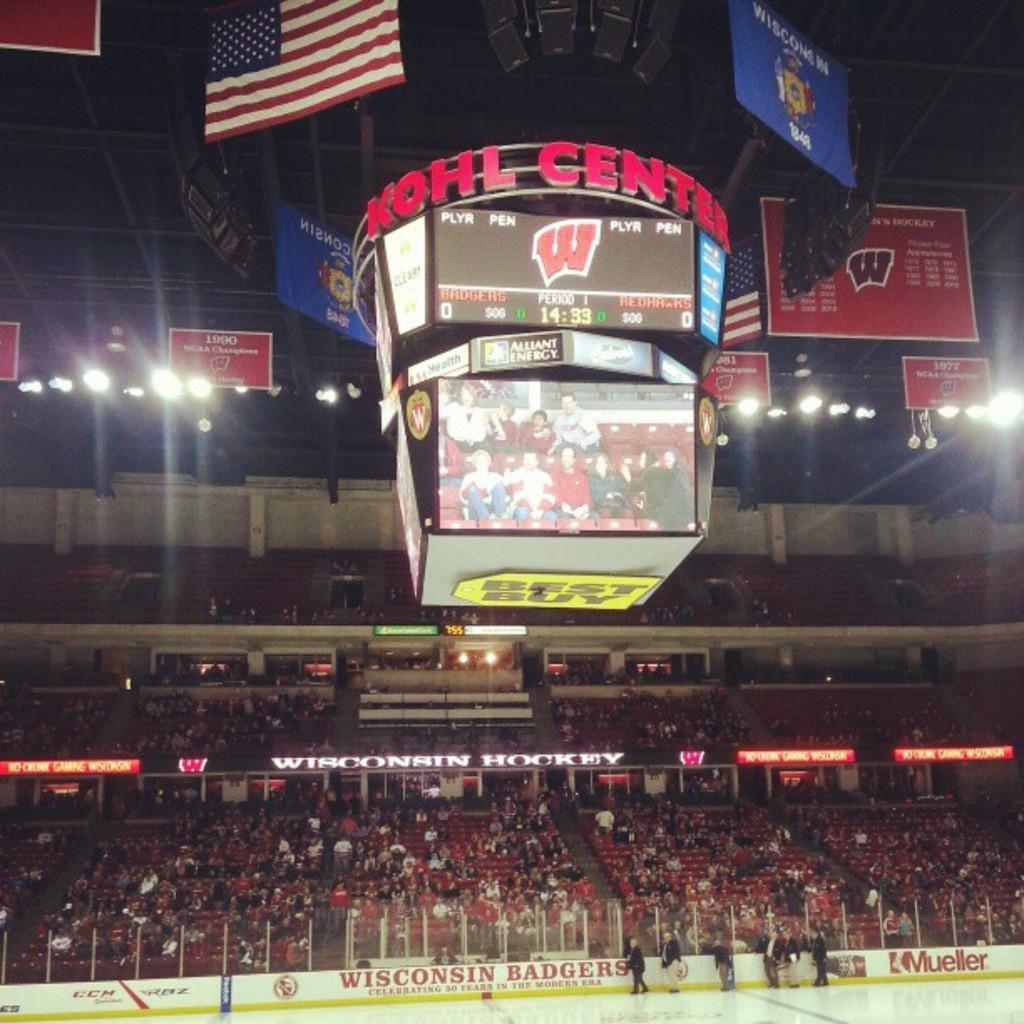<image>
Create a compact narrative representing the image presented. The arena in the photo is called the Kohl Center. 